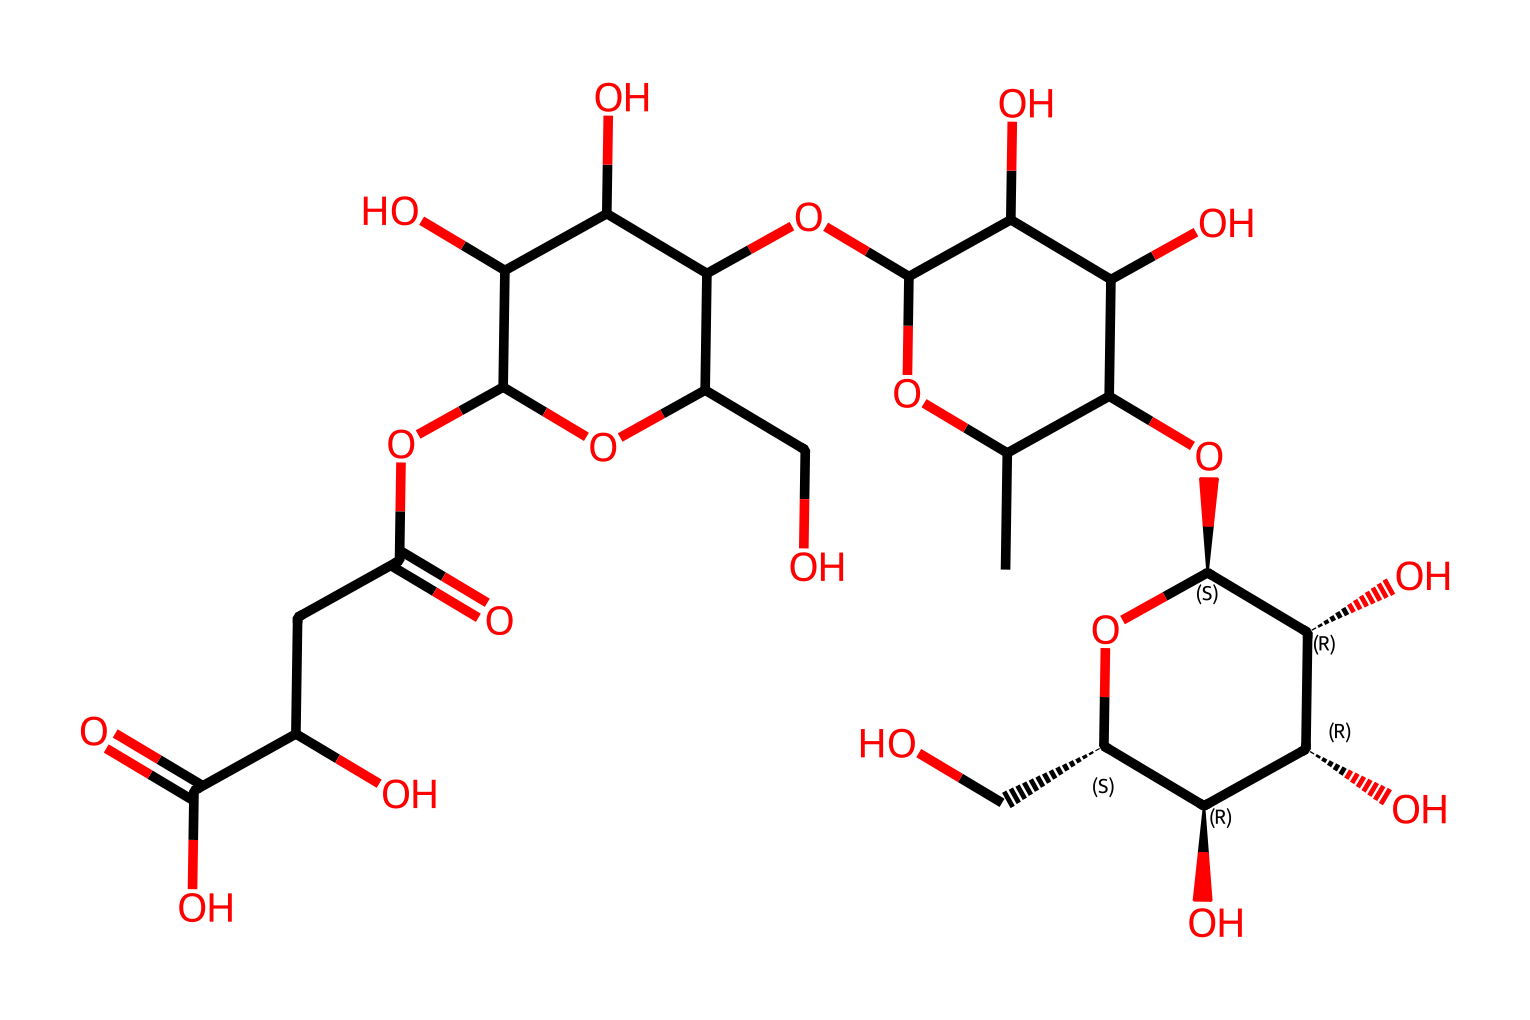What is the primary functional group present in xanthan gum? The chemical structure contains multiple hydroxyl groups (-OH), which are characteristic of polysaccharides, particularly in xanthan gum.
Answer: hydroxyl How many rings are present in the xanthan gum structure? By analyzing the chemical structure, we can identify one cyclic structure (a ring) formed by the two carbon atoms linked with oxygen.
Answer: one What type of polymer is xanthan gum classified as? Xanthan gum is classified as a polysaccharide because it is a carbohydrate polymer made of sugar units.
Answer: polysaccharide Does xanthan gum exhibit pseudoplastic behavior? Xanthan gum is known for its pseudoplastic behavior, meaning it becomes less viscous under shear stress, a characteristic of Non-Newtonian fluids.
Answer: yes What role does the sulfonate group play in xanthan gum's properties? The sulfonate group can enhance the solubility and viscosity of xanthan gum in solution, affecting its overall rheological properties.
Answer: enhances viscosity Which sugar units are predominant in the molecular arrangement of xanthan gum? The structure primarily includes glucose units as part of its polymer chain, crucial to its properties as a thickener.
Answer: glucose 